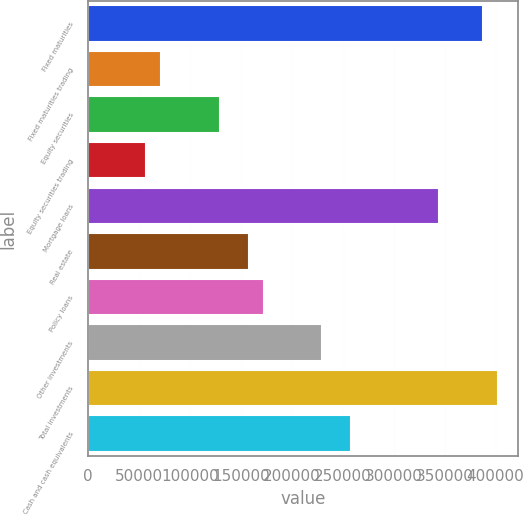Convert chart to OTSL. <chart><loc_0><loc_0><loc_500><loc_500><bar_chart><fcel>Fixed maturities<fcel>Fixed maturities trading<fcel>Equity securities<fcel>Equity securities trading<fcel>Mortgage loans<fcel>Real estate<fcel>Policy loans<fcel>Other investments<fcel>Total investments<fcel>Cash and cash equivalents<nl><fcel>387877<fcel>71829.1<fcel>129292<fcel>57463.3<fcel>344779<fcel>158024<fcel>172390<fcel>229853<fcel>402242<fcel>258584<nl></chart> 